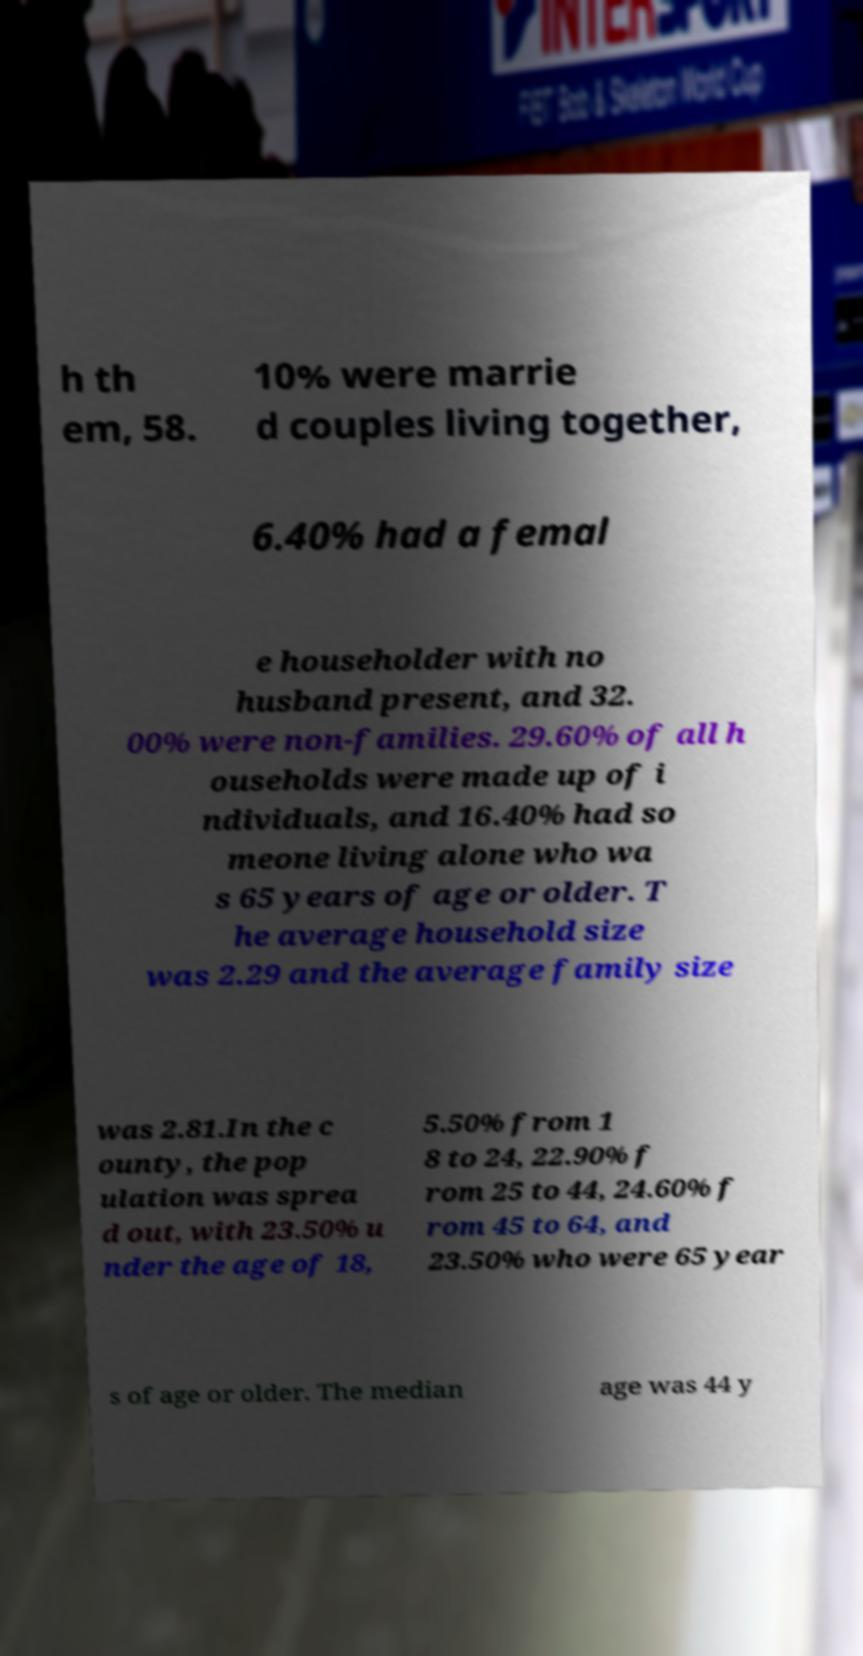For documentation purposes, I need the text within this image transcribed. Could you provide that? h th em, 58. 10% were marrie d couples living together, 6.40% had a femal e householder with no husband present, and 32. 00% were non-families. 29.60% of all h ouseholds were made up of i ndividuals, and 16.40% had so meone living alone who wa s 65 years of age or older. T he average household size was 2.29 and the average family size was 2.81.In the c ounty, the pop ulation was sprea d out, with 23.50% u nder the age of 18, 5.50% from 1 8 to 24, 22.90% f rom 25 to 44, 24.60% f rom 45 to 64, and 23.50% who were 65 year s of age or older. The median age was 44 y 